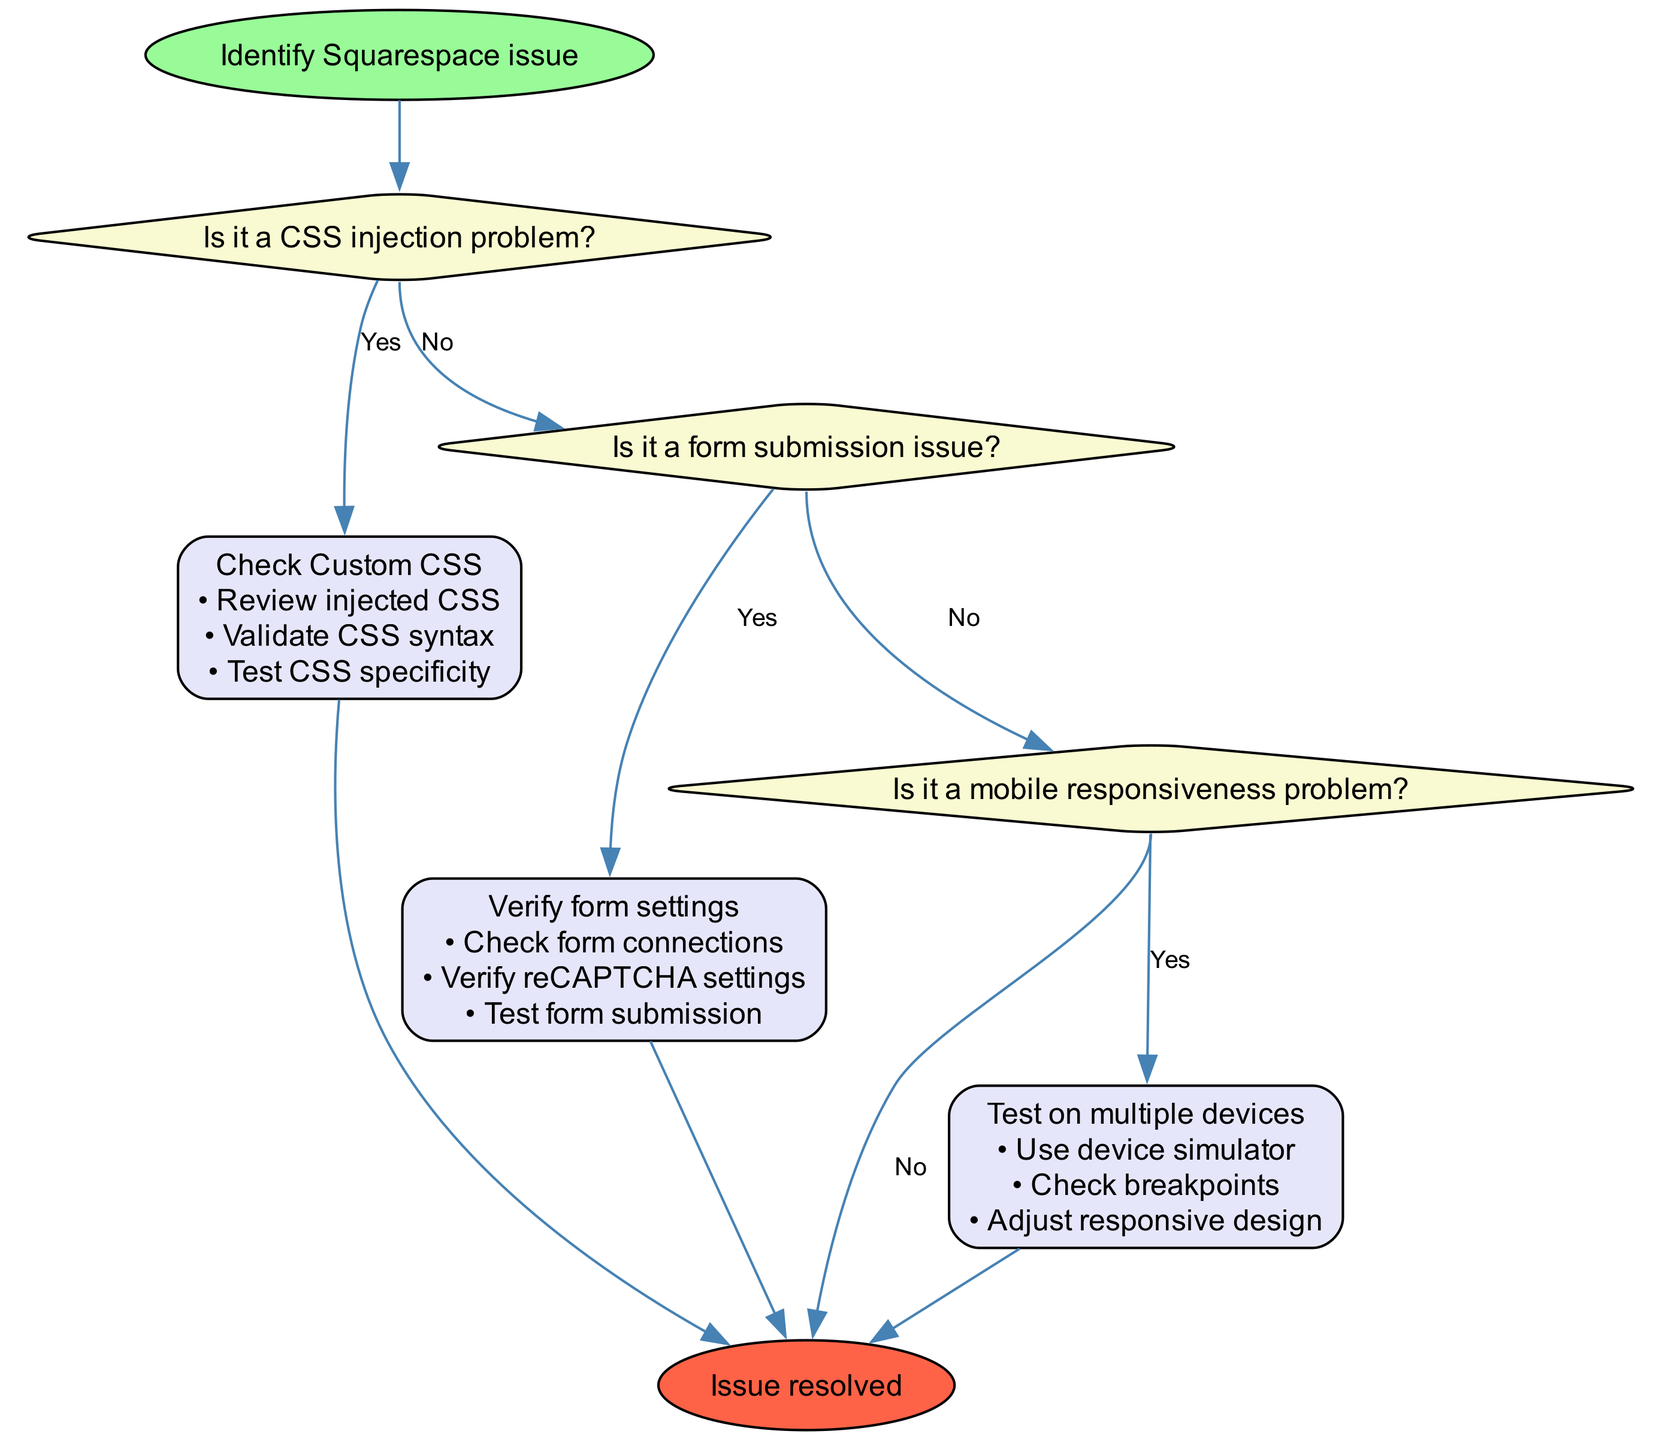What is the first action to take if there is a CSS injection problem? The first action after identifying a CSS injection problem is to "Check Custom CSS". This is found directly as the first action linked under the decision node that addresses the CSS issue.
Answer: Check Custom CSS How many decisions are present in the diagram? The diagram includes three decision nodes: one for CSS injection, one for form submission, and one for mobile responsiveness. Analyzing the structure confirms these three distinct points of decision.
Answer: 3 What should you do if the issue is not mobile responsiveness? If the issue is not mobile responsiveness, the next step is to "Contact Squarespace support". This is the final decision output when neither of the first two issues is confirmed, leading to support.
Answer: Contact Squarespace support What is the action to take if the form submission issue is confirmed? The action to take for a confirmed form submission issue is to "Verify form settings". This action connects directly from the decision node that identifies the form submission as the problem.
Answer: Verify form settings What happens after you Check Custom CSS? After checking Custom CSS, several steps should be taken, including reviewing injected CSS, validating CSS syntax, and testing CSS specificity. These steps are detailed under the action node that follows the initial decision.
Answer: Review injected CSS, Validate CSS syntax, Test CSS specificity If the form settings are verified, which step follows next? If the form settings are verified, the next step is to "Test form submission". This is the subsequent action that occurs if the form submission issue has been validated.
Answer: Test form submission What final step is indicated if the last decision shows 'No'? If the last decision (regarding mobile responsiveness) shows 'No', the indicated final step is to "Contact Squarespace support". This is linked from the last decision node indicating that no issues were resolved from the previous checks.
Answer: Contact Squarespace support How many steps are involved in the "Test on multiple devices" action? The "Test on multiple devices" action contains three steps: using a device simulator, checking breakpoints, and adjusting responsive design. Counting the steps provided for this specific action yields three distinct items.
Answer: 3 